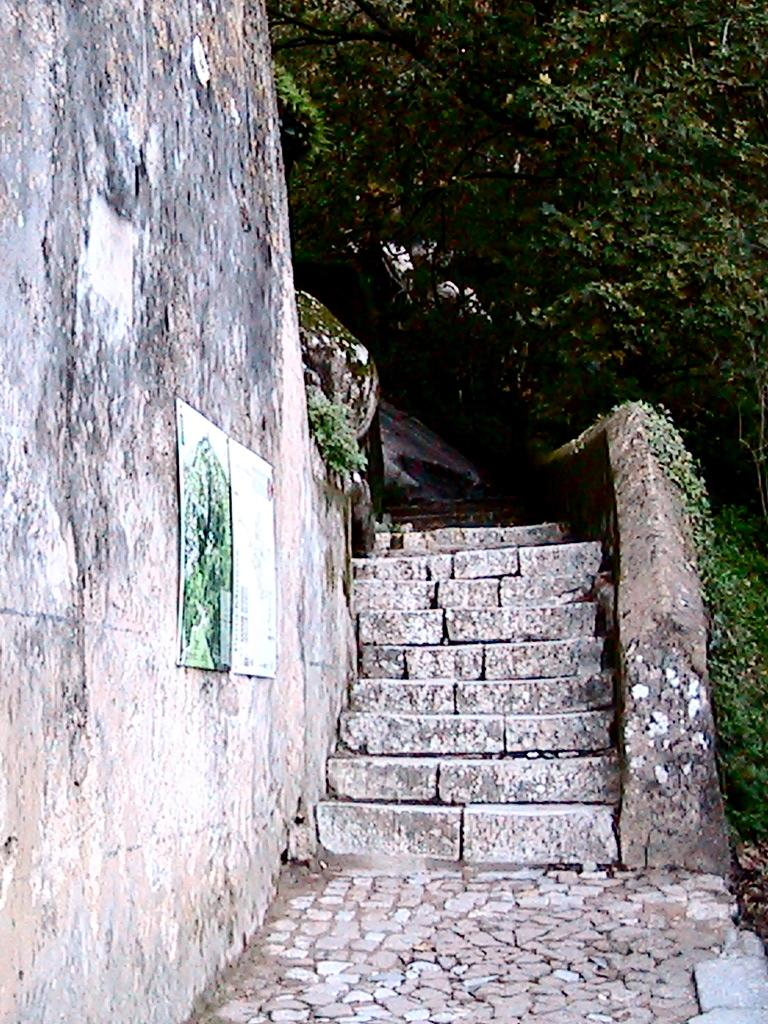What is present on the wall in the image? There are objects on the wall in the image. What architectural feature can be seen in the image? There are steps in the image. What type of vegetation is visible in the image? There are plants and trees in the image. What type of whip is being used to trim the trees in the image? There is no whip present in the image, nor is anyone trimming trees. 